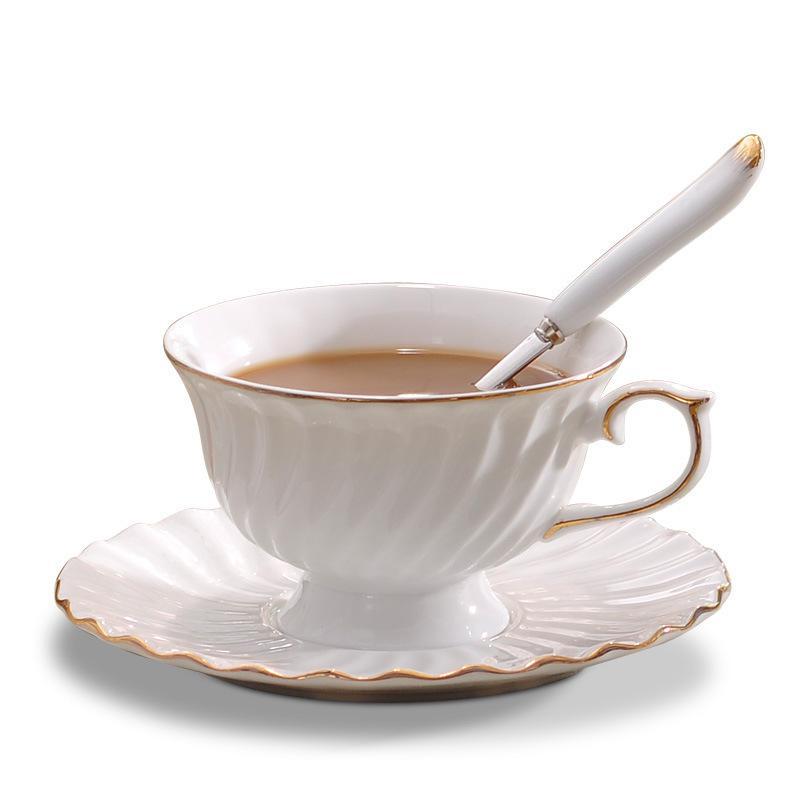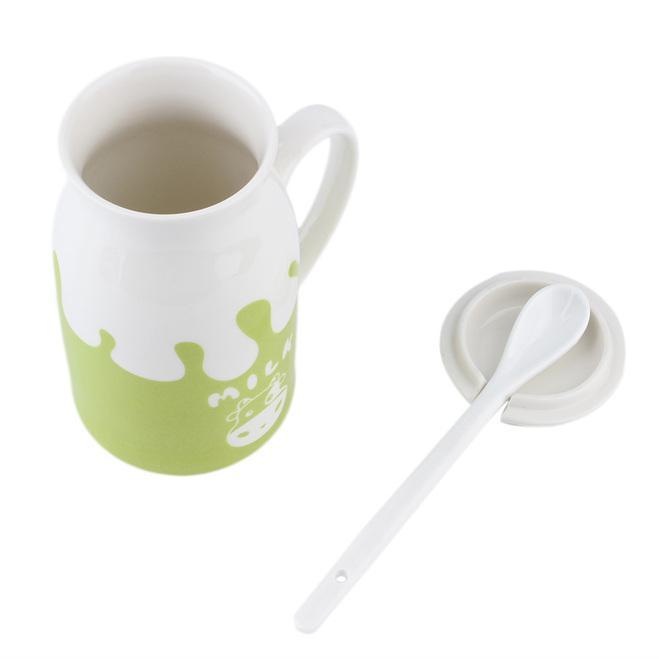The first image is the image on the left, the second image is the image on the right. Given the left and right images, does the statement "In 1 of the images, an empty cup has a spoon in it." hold true? Answer yes or no. No. The first image is the image on the left, the second image is the image on the right. For the images shown, is this caption "Steam is visible in one of the images." true? Answer yes or no. No. 